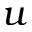Convert formula to latex. <formula><loc_0><loc_0><loc_500><loc_500>u</formula> 